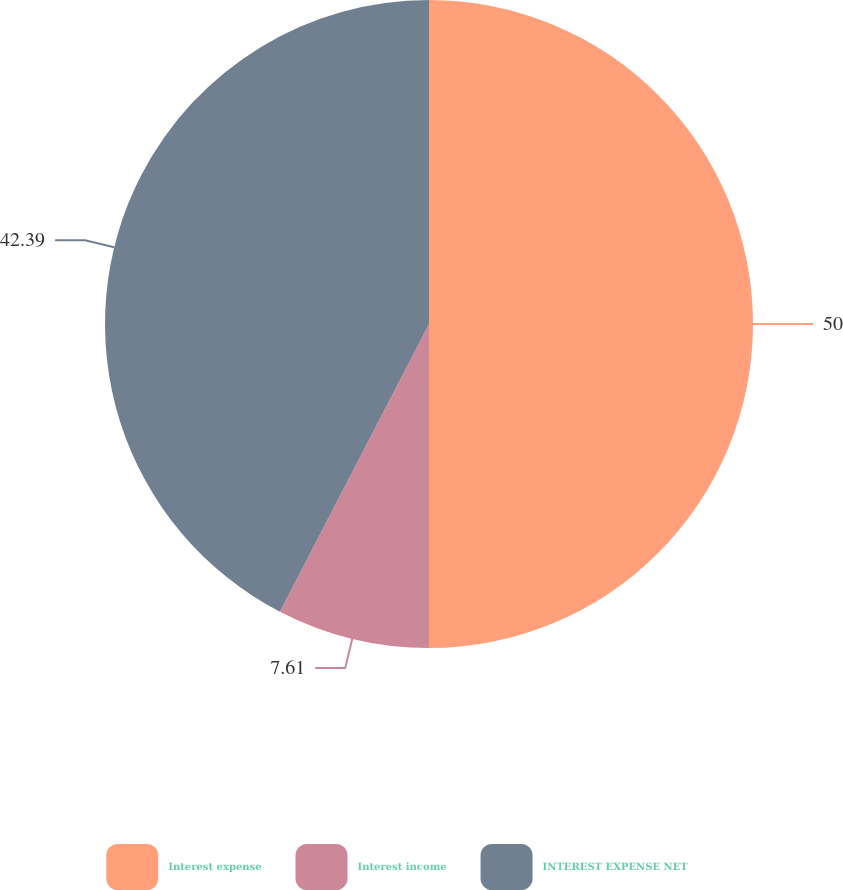<chart> <loc_0><loc_0><loc_500><loc_500><pie_chart><fcel>Interest expense<fcel>Interest income<fcel>INTEREST EXPENSE NET<nl><fcel>50.0%<fcel>7.61%<fcel>42.39%<nl></chart> 